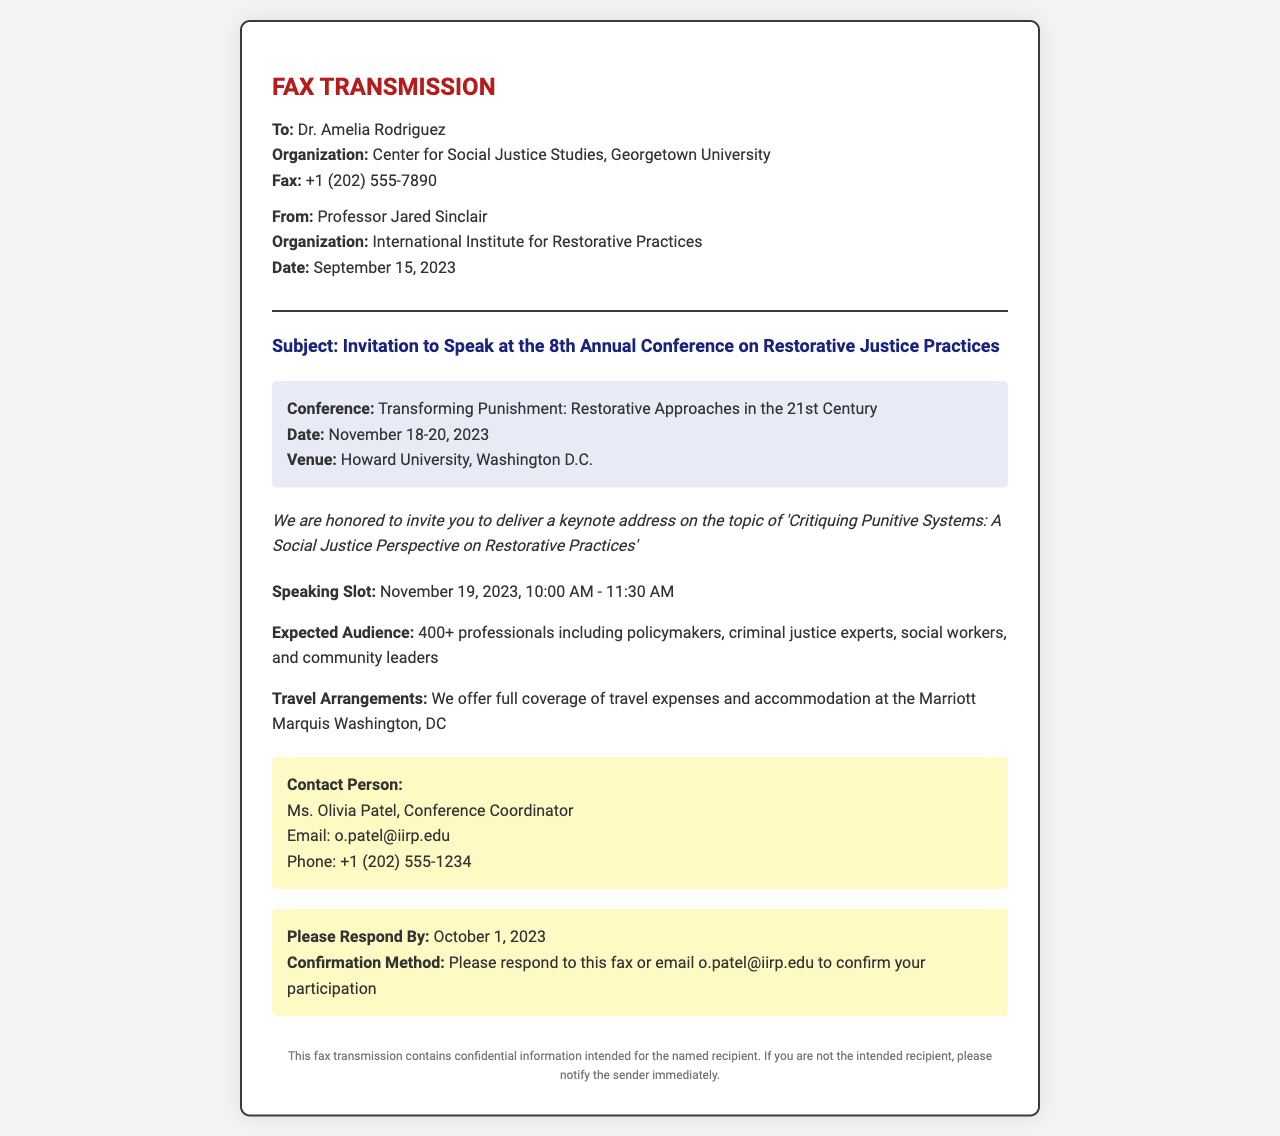What is the name of the recipient? The recipient is identified in the fax as Dr. Amelia Rodriguez.
Answer: Dr. Amelia Rodriguez What is the date of the conference? The conference is scheduled for November 18-20, 2023.
Answer: November 18-20, 2023 What is the title of the keynote address? The title of the keynote address is provided in the invitation text.
Answer: Critiquing Punitive Systems: A Social Justice Perspective on Restorative Practices Who is the contact person for the conference? The fax lists Ms. Olivia Patel as the contact person for conference inquiries.
Answer: Ms. Olivia Patel What is the expected audience size? The expected audience is mentioned in the document as being over 400 participants.
Answer: 400+ Why is Dr. Amelia Rodriguez invited to speak? The invitation highlights the focus on critiquing punitive systems from a social justice perspective, indicating her expertise in this area.
Answer: To deliver a keynote address What is the date by which a response is requested? The fax specifies that a response is expected by October 1, 2023.
Answer: October 1, 2023 What venue will host the conference? The venue for the conference is listed as Howard University in Washington D.C.
Answer: Howard University, Washington D.C What are the travel arrangements offered? The document states that full coverage of travel expenses and accommodation will be provided.
Answer: Full coverage of travel expenses and accommodation 